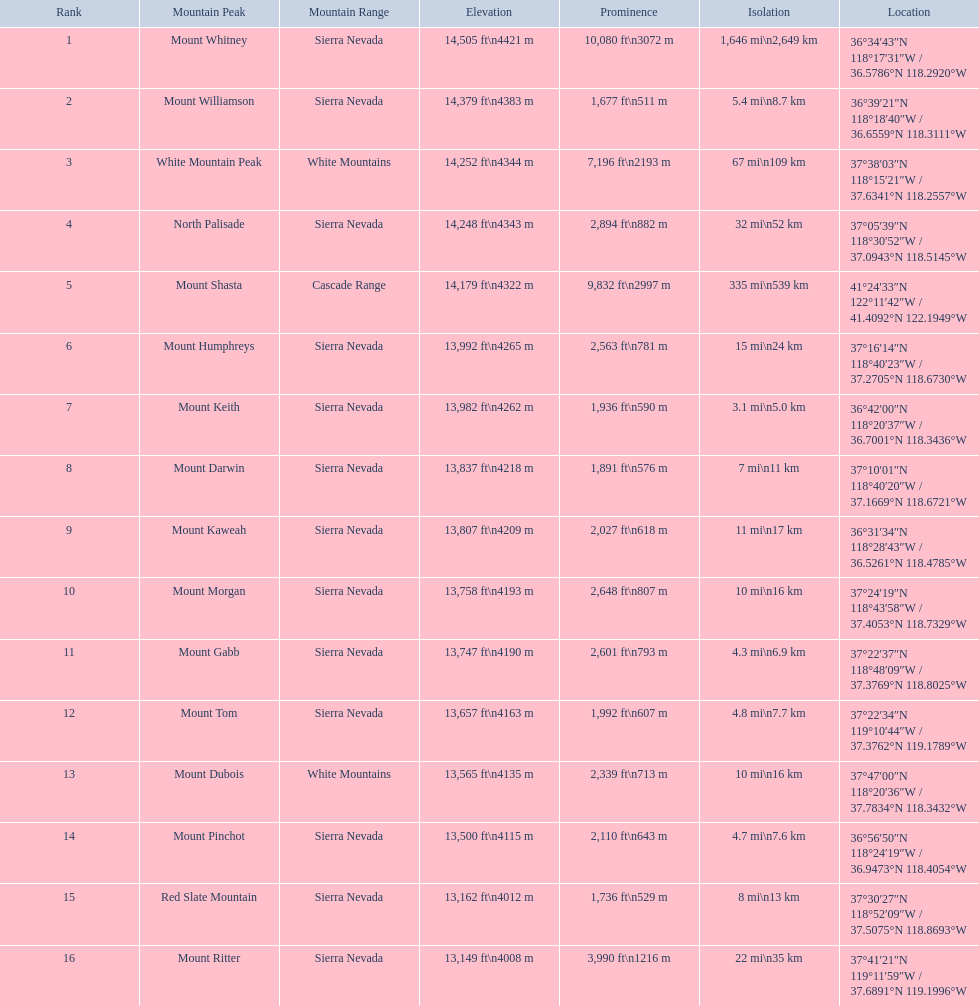What are the peaks in california? Mount Whitney, Mount Williamson, White Mountain Peak, North Palisade, Mount Shasta, Mount Humphreys, Mount Keith, Mount Darwin, Mount Kaweah, Mount Morgan, Mount Gabb, Mount Tom, Mount Dubois, Mount Pinchot, Red Slate Mountain, Mount Ritter. What are the peaks in sierra nevada, california? Mount Whitney, Mount Williamson, North Palisade, Mount Humphreys, Mount Keith, Mount Darwin, Mount Kaweah, Mount Morgan, Mount Gabb, Mount Tom, Mount Pinchot, Red Slate Mountain, Mount Ritter. What are the heights of the peaks in sierra nevada? 14,505 ft\n4421 m, 14,379 ft\n4383 m, 14,248 ft\n4343 m, 13,992 ft\n4265 m, 13,982 ft\n4262 m, 13,837 ft\n4218 m, 13,807 ft\n4209 m, 13,758 ft\n4193 m, 13,747 ft\n4190 m, 13,657 ft\n4163 m, 13,500 ft\n4115 m, 13,162 ft\n4012 m, 13,149 ft\n4008 m. Which is the highest? Mount Whitney. What are the peak heights? 14,505 ft\n4421 m, 14,379 ft\n4383 m, 14,252 ft\n4344 m, 14,248 ft\n4343 m, 14,179 ft\n4322 m, 13,992 ft\n4265 m, 13,982 ft\n4262 m, 13,837 ft\n4218 m, 13,807 ft\n4209 m, 13,758 ft\n4193 m, 13,747 ft\n4190 m, 13,657 ft\n4163 m, 13,565 ft\n4135 m, 13,500 ft\n4115 m, 13,162 ft\n4012 m, 13,149 ft\n4008 m. Which is the tallest among them? 14,505 ft\n4421 m. Which peak measures 14,505 feet in height? Mount Whitney. 